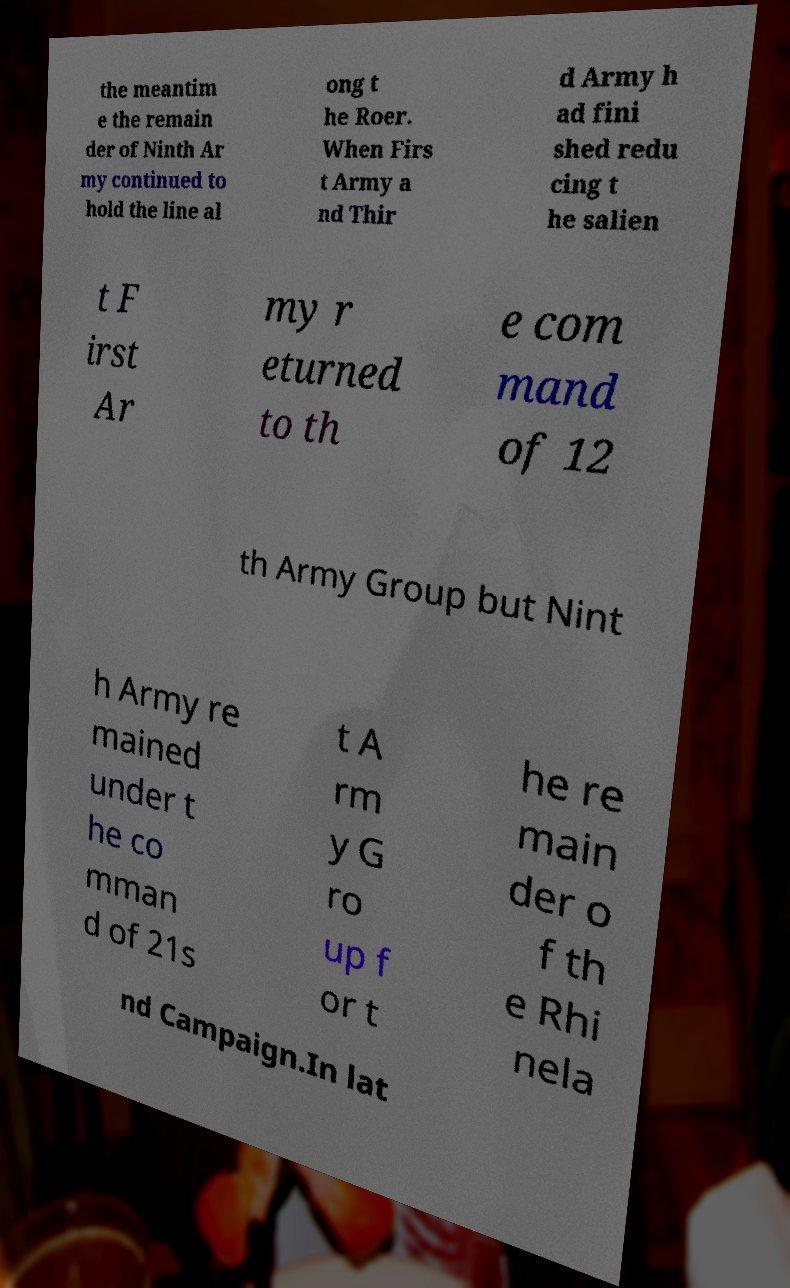For documentation purposes, I need the text within this image transcribed. Could you provide that? the meantim e the remain der of Ninth Ar my continued to hold the line al ong t he Roer. When Firs t Army a nd Thir d Army h ad fini shed redu cing t he salien t F irst Ar my r eturned to th e com mand of 12 th Army Group but Nint h Army re mained under t he co mman d of 21s t A rm y G ro up f or t he re main der o f th e Rhi nela nd Campaign.In lat 